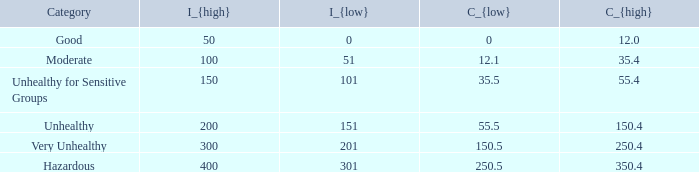What's the C_{high} when the C_{low} value is 250.5? 350.4. 